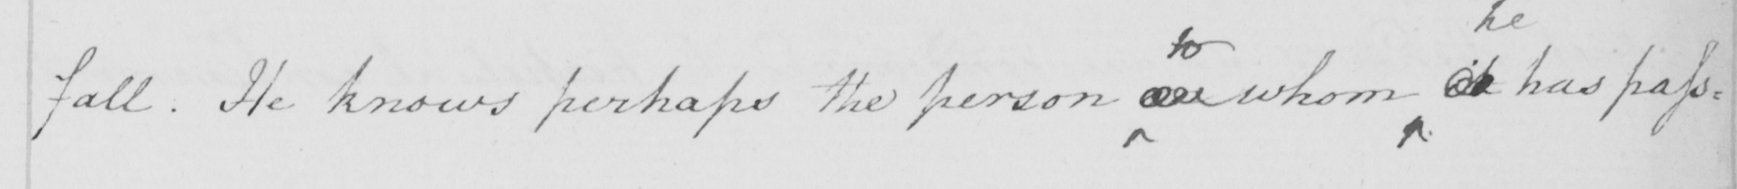Please transcribe the handwritten text in this image. fall . He knows perhaps the person on whom it has pass= 